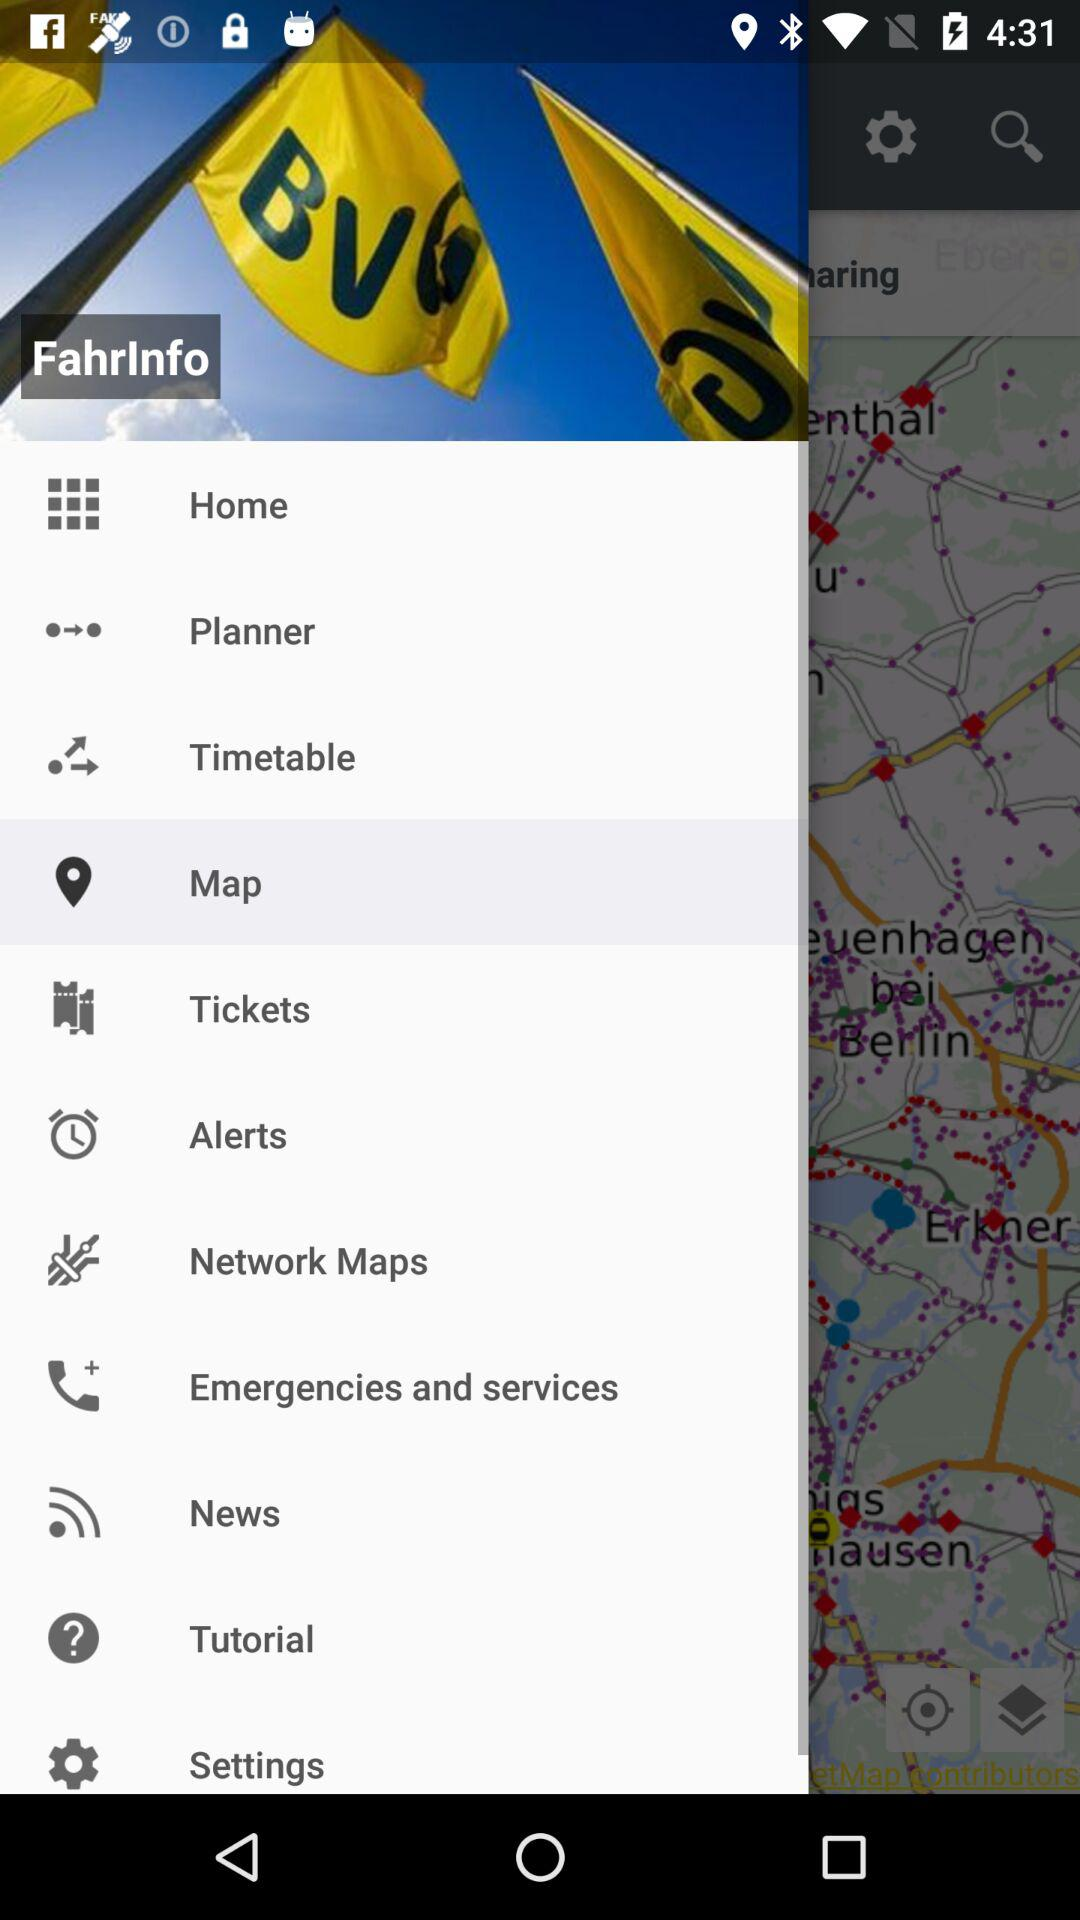What is the profile name?
When the provided information is insufficient, respond with <no answer>. <no answer> 